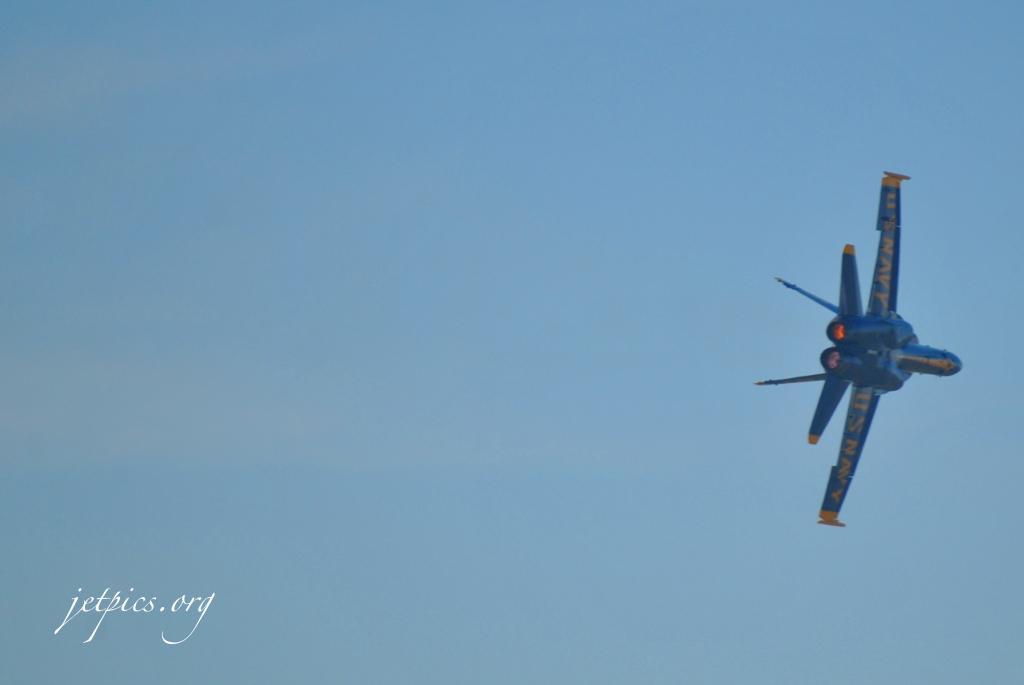How would you summarize this image in a sentence or two? In this picture I can see a fighter jet and I can see text at the bottom left corner of the picture and I can see a blue cloudy sky. 